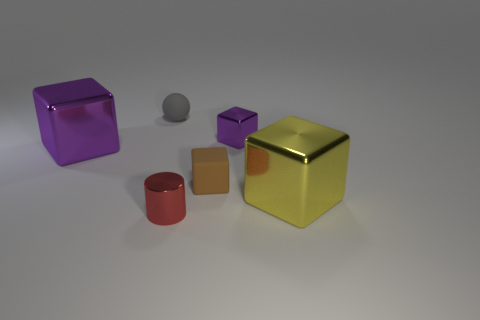Is there any other thing that is made of the same material as the tiny sphere?
Your response must be concise. Yes. There is a big object that is the same color as the small metallic block; what shape is it?
Your response must be concise. Cube. Is the number of red shiny objects that are behind the tiny cylinder greater than the number of small brown matte cubes?
Ensure brevity in your answer.  No. What color is the tiny rubber ball?
Your answer should be very brief. Gray. The small metal object in front of the metallic block that is in front of the big object behind the big yellow shiny thing is what shape?
Provide a succinct answer. Cylinder. There is a cube that is right of the brown block and behind the big yellow block; what material is it?
Your answer should be compact. Metal. There is a metal thing in front of the big cube in front of the rubber block; what shape is it?
Give a very brief answer. Cylinder. Is there anything else that has the same color as the tiny metal cube?
Give a very brief answer. Yes. There is a yellow metallic object; is its size the same as the rubber thing that is in front of the small gray sphere?
Your answer should be very brief. No. How many large things are either brown objects or metallic cylinders?
Keep it short and to the point. 0. 